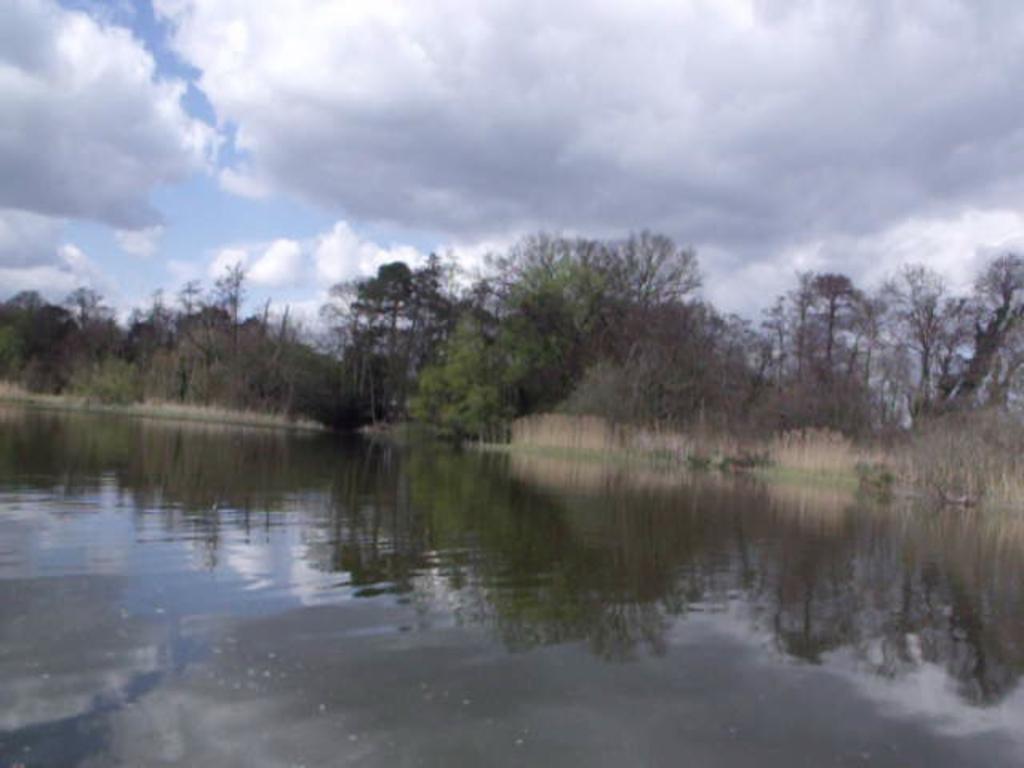Could you give a brief overview of what you see in this image? In this image in the front there is water. In the background there are trees and the sky is cloudy. 